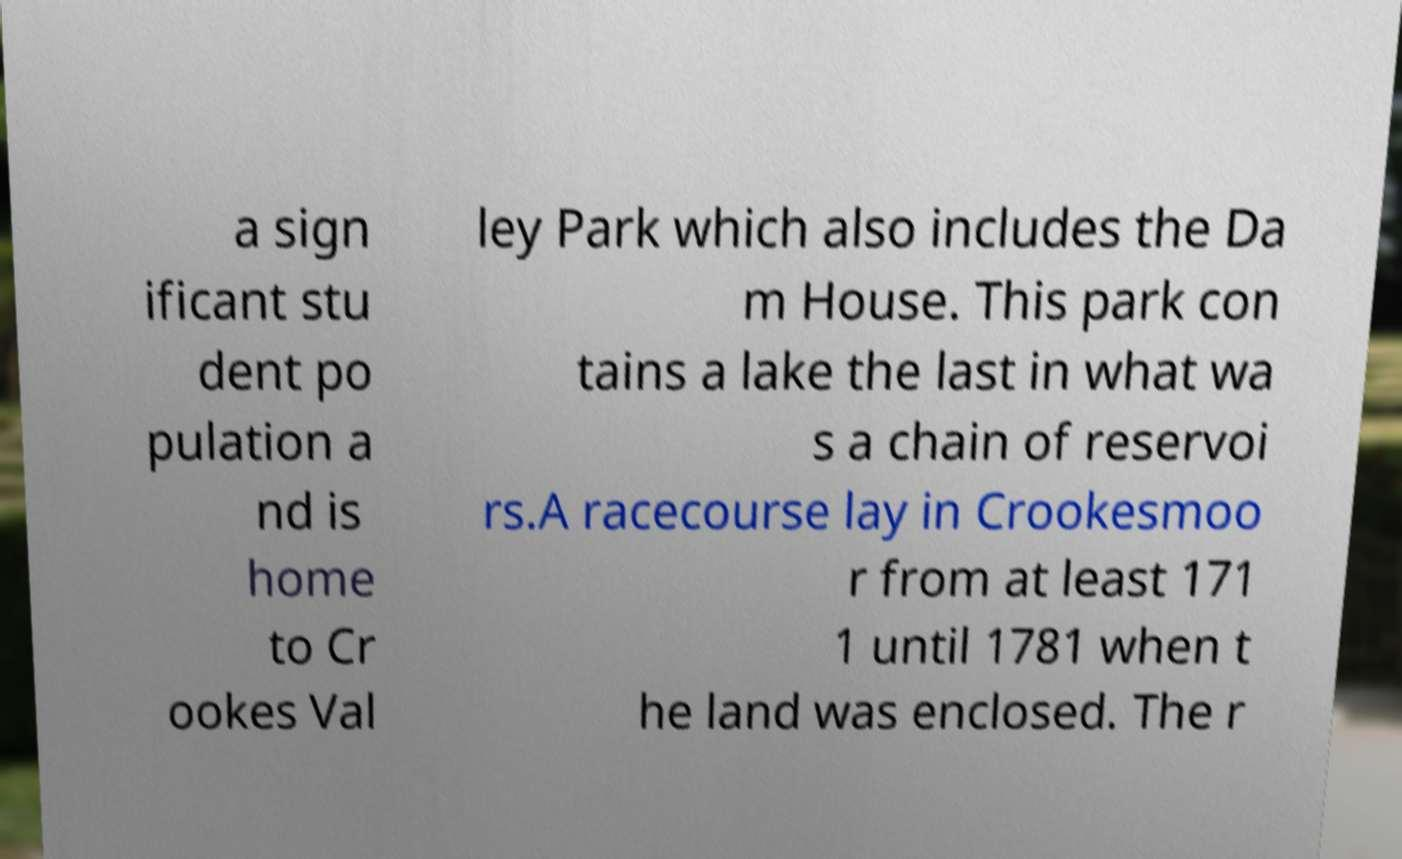For documentation purposes, I need the text within this image transcribed. Could you provide that? a sign ificant stu dent po pulation a nd is home to Cr ookes Val ley Park which also includes the Da m House. This park con tains a lake the last in what wa s a chain of reservoi rs.A racecourse lay in Crookesmoo r from at least 171 1 until 1781 when t he land was enclosed. The r 